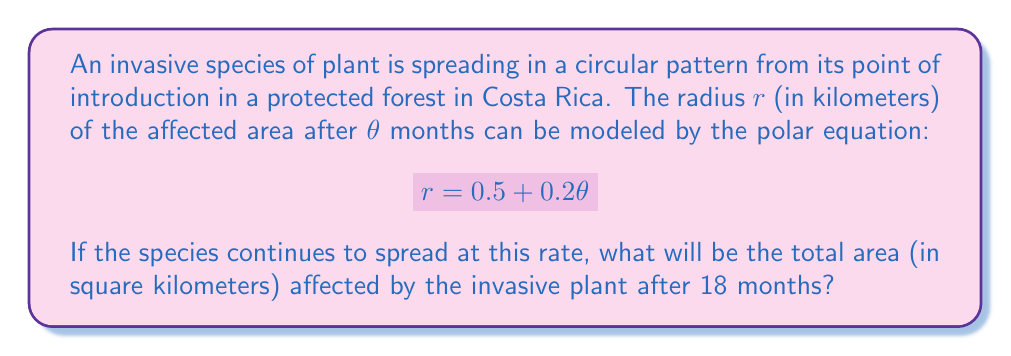Provide a solution to this math problem. To solve this problem, we need to follow these steps:

1) First, we need to understand what the equation $r = 0.5 + 0.2\theta$ represents. This is a polar equation where:
   - $r$ is the radius in kilometers
   - $\theta$ is the time in months
   - 0.5 km is the initial radius of the affected area
   - The species spreads at a rate of 0.2 km per month

2) We need to find the radius after 18 months. Let's substitute $\theta = 18$ into the equation:

   $$r = 0.5 + 0.2(18) = 0.5 + 3.6 = 4.1$$

   So, after 18 months, the affected area will have a radius of 4.1 km.

3) Now that we have the radius, we need to calculate the area. The formula for the area of a circle is $A = \pi r^2$.

4) Let's substitute our radius value:

   $$A = \pi (4.1)^2 = 16.81\pi$$

5) Calculate this value:

   $$A = 16.81 \times 3.14159... \approx 52.81$$

Therefore, the total affected area after 18 months will be approximately 52.81 square kilometers.
Answer: 52.81 square kilometers 